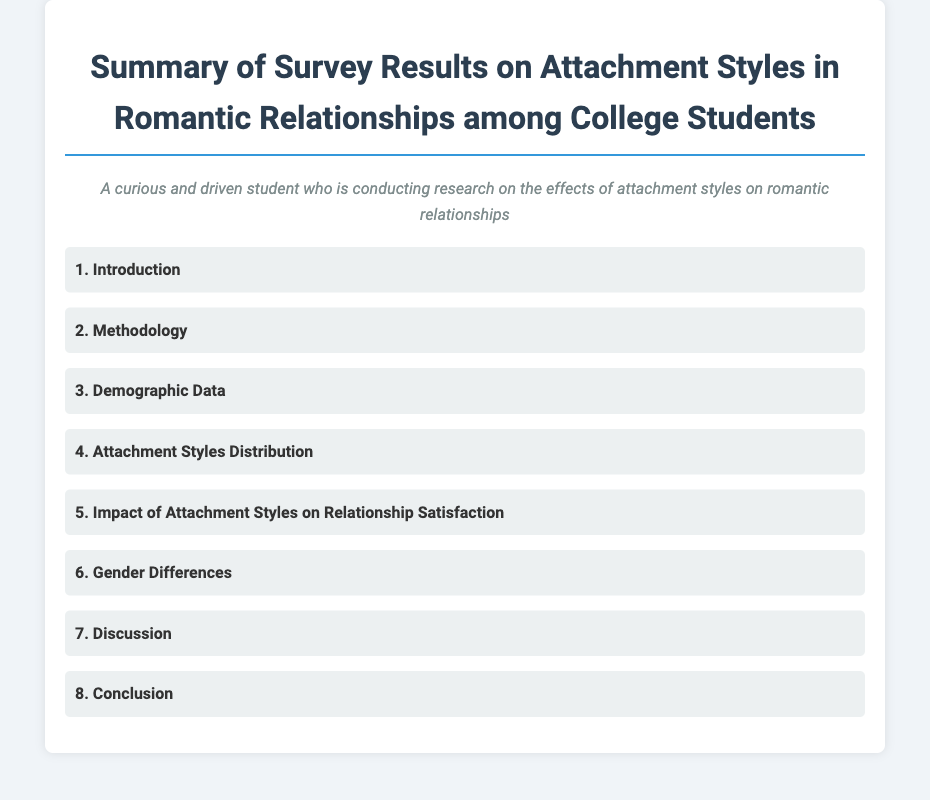What is the title of the document? The title appears at the top of the document and provides the main topic of discussion.
Answer: Summary of Survey Results on Attachment Styles in Romantic Relationships among College Students How many main sections are in the document? The main sections are listed in the index, which provides a count of the items.
Answer: 8 What section discusses the effects of attachment styles on relationship satisfaction? The index lists section titles that indicate their content, pointing to the section addressing this specific topic.
Answer: Impact of Attachment Styles on Relationship Satisfaction Which section addresses differences in attachment styles based on gender? The specific section about gender differences is clearly labeled in the index.
Answer: Gender Differences What is the heading for the methodology part of the survey? The index includes a specific title that denotes the methodology used in the document.
Answer: Methodology What does the persona indicate about the target audience of the document? The persona provides insight about who the document is aimed at or who the author is.
Answer: A curious and driven student Which section would likely contain the survey results? The section that typically contains detailed survey findings is indicated in the index.
Answer: Attachment Styles Distribution What is the last section in the document? The last section listed in the index will denote the conclusion or final thoughts of the document.
Answer: Conclusion 